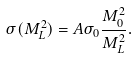<formula> <loc_0><loc_0><loc_500><loc_500>\sigma ( M ^ { 2 } _ { L } ) = A \sigma _ { 0 } \frac { M _ { 0 } ^ { 2 } } { M ^ { 2 } _ { L } } .</formula> 